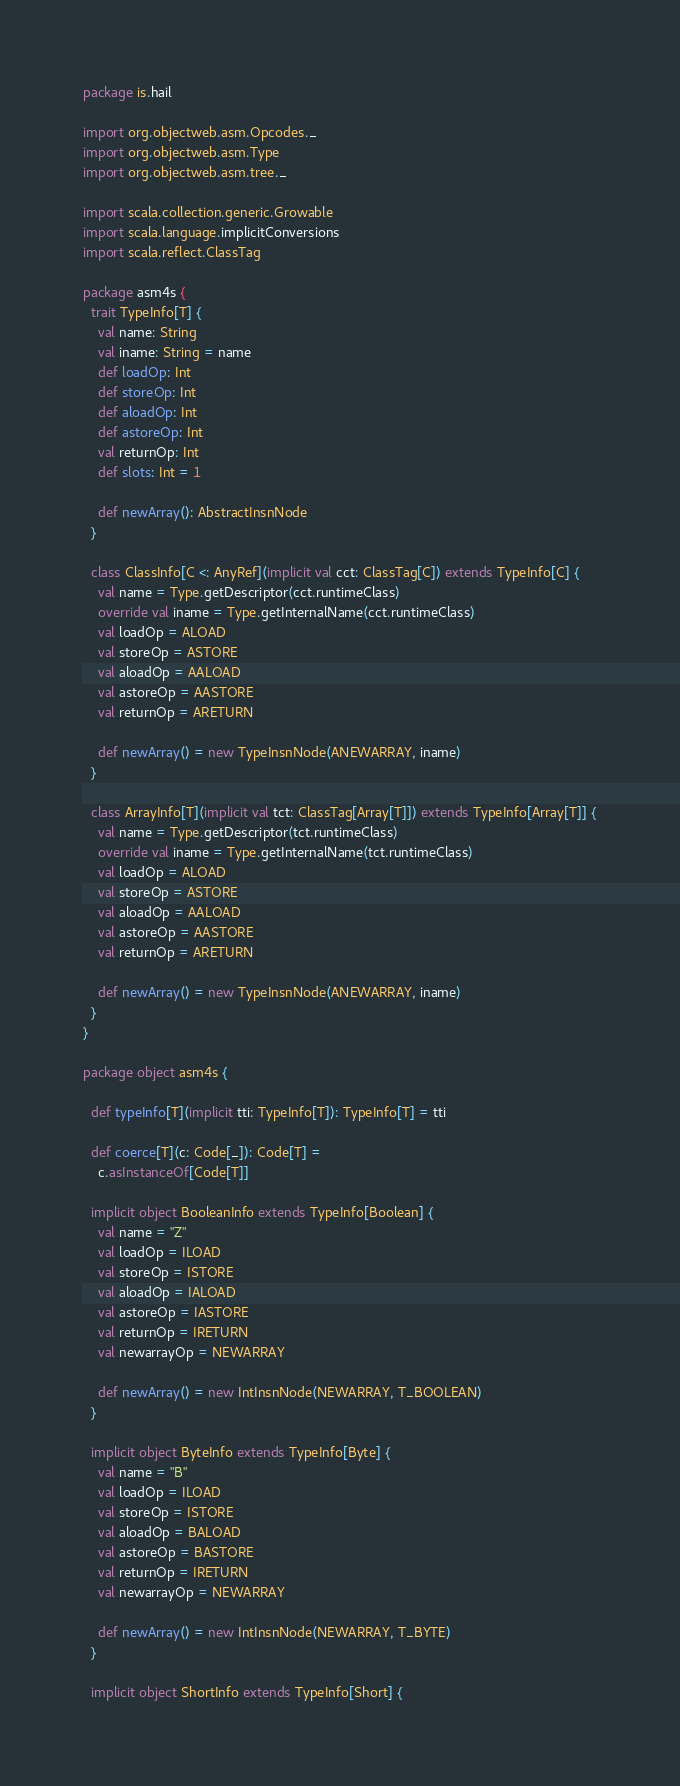<code> <loc_0><loc_0><loc_500><loc_500><_Scala_>package is.hail

import org.objectweb.asm.Opcodes._
import org.objectweb.asm.Type
import org.objectweb.asm.tree._

import scala.collection.generic.Growable
import scala.language.implicitConversions
import scala.reflect.ClassTag

package asm4s {
  trait TypeInfo[T] {
    val name: String
    val iname: String = name
    def loadOp: Int
    def storeOp: Int
    def aloadOp: Int
    def astoreOp: Int
    val returnOp: Int
    def slots: Int = 1

    def newArray(): AbstractInsnNode
  }

  class ClassInfo[C <: AnyRef](implicit val cct: ClassTag[C]) extends TypeInfo[C] {
    val name = Type.getDescriptor(cct.runtimeClass)
    override val iname = Type.getInternalName(cct.runtimeClass)
    val loadOp = ALOAD
    val storeOp = ASTORE
    val aloadOp = AALOAD
    val astoreOp = AASTORE
    val returnOp = ARETURN

    def newArray() = new TypeInsnNode(ANEWARRAY, iname)
  }

  class ArrayInfo[T](implicit val tct: ClassTag[Array[T]]) extends TypeInfo[Array[T]] {
    val name = Type.getDescriptor(tct.runtimeClass)
    override val iname = Type.getInternalName(tct.runtimeClass)
    val loadOp = ALOAD
    val storeOp = ASTORE
    val aloadOp = AALOAD
    val astoreOp = AASTORE
    val returnOp = ARETURN

    def newArray() = new TypeInsnNode(ANEWARRAY, iname)
  }
}

package object asm4s {

  def typeInfo[T](implicit tti: TypeInfo[T]): TypeInfo[T] = tti

  def coerce[T](c: Code[_]): Code[T] =
    c.asInstanceOf[Code[T]]

  implicit object BooleanInfo extends TypeInfo[Boolean] {
    val name = "Z"
    val loadOp = ILOAD
    val storeOp = ISTORE
    val aloadOp = IALOAD
    val astoreOp = IASTORE
    val returnOp = IRETURN
    val newarrayOp = NEWARRAY

    def newArray() = new IntInsnNode(NEWARRAY, T_BOOLEAN)
  }

  implicit object ByteInfo extends TypeInfo[Byte] {
    val name = "B"
    val loadOp = ILOAD
    val storeOp = ISTORE
    val aloadOp = BALOAD
    val astoreOp = BASTORE
    val returnOp = IRETURN
    val newarrayOp = NEWARRAY

    def newArray() = new IntInsnNode(NEWARRAY, T_BYTE)
  }

  implicit object ShortInfo extends TypeInfo[Short] {</code> 